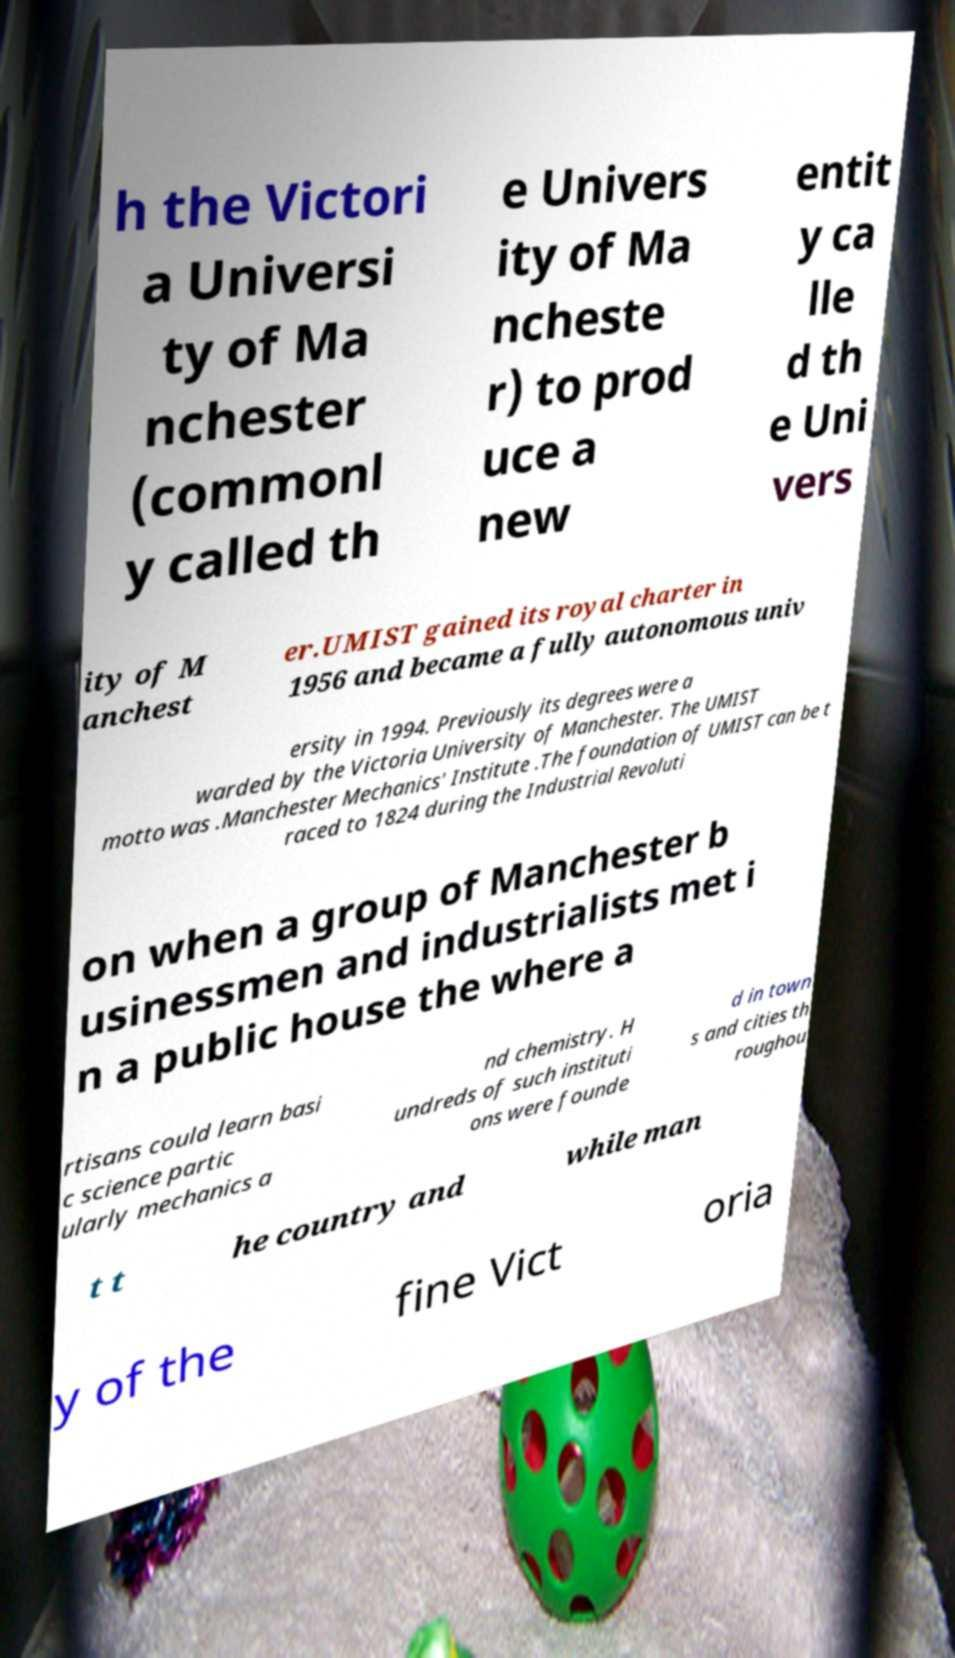There's text embedded in this image that I need extracted. Can you transcribe it verbatim? h the Victori a Universi ty of Ma nchester (commonl y called th e Univers ity of Ma ncheste r) to prod uce a new entit y ca lle d th e Uni vers ity of M anchest er.UMIST gained its royal charter in 1956 and became a fully autonomous univ ersity in 1994. Previously its degrees were a warded by the Victoria University of Manchester. The UMIST motto was .Manchester Mechanics' Institute .The foundation of UMIST can be t raced to 1824 during the Industrial Revoluti on when a group of Manchester b usinessmen and industrialists met i n a public house the where a rtisans could learn basi c science partic ularly mechanics a nd chemistry. H undreds of such instituti ons were founde d in town s and cities th roughou t t he country and while man y of the fine Vict oria 